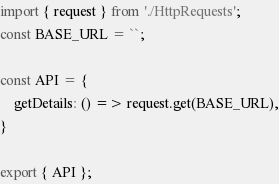<code> <loc_0><loc_0><loc_500><loc_500><_JavaScript_>import { request } from './HttpRequests';
const BASE_URL = ``;

const API = {
    getDetails: () => request.get(BASE_URL),
}

export { API };</code> 